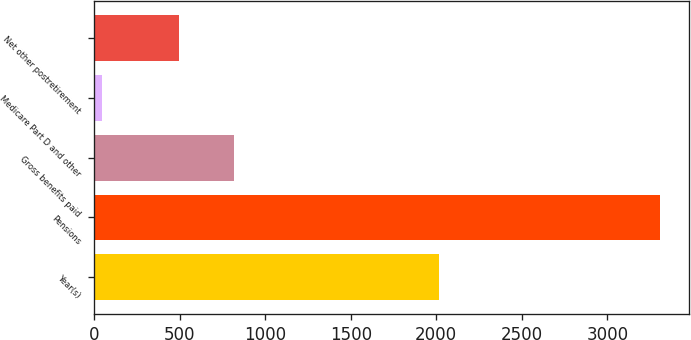<chart> <loc_0><loc_0><loc_500><loc_500><bar_chart><fcel>Year(s)<fcel>Pensions<fcel>Gross benefits paid<fcel>Medicare Part D and other<fcel>Net other postretirement<nl><fcel>2015<fcel>3309<fcel>820<fcel>49<fcel>494<nl></chart> 